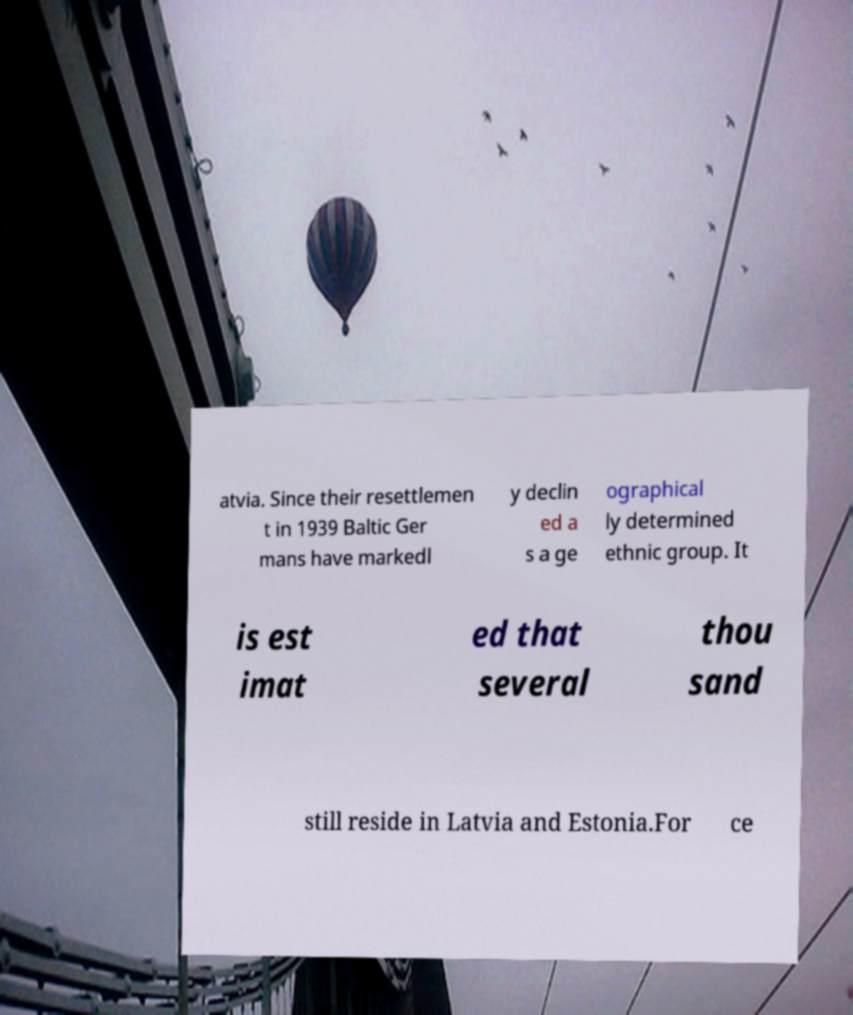Please read and relay the text visible in this image. What does it say? atvia. Since their resettlemen t in 1939 Baltic Ger mans have markedl y declin ed a s a ge ographical ly determined ethnic group. It is est imat ed that several thou sand still reside in Latvia and Estonia.For ce 